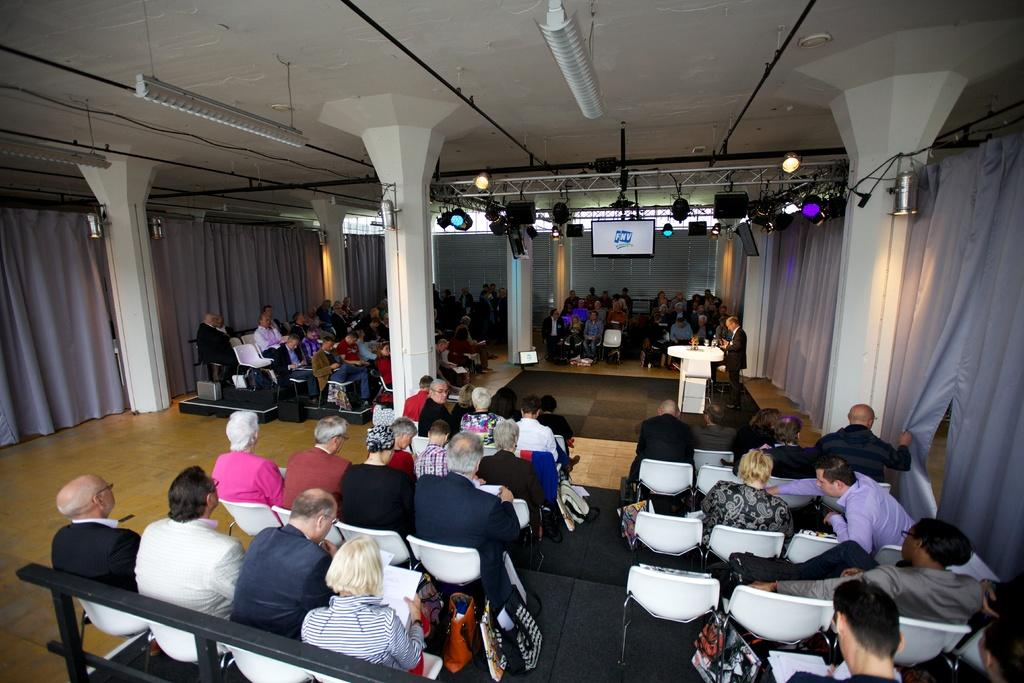What are the people in the image doing? There is a group of people sitting on chairs in the image. What can be seen near the group of people? There is a man standing near a podium in the image. What is visible at the top of the image? There are lights visible at the top of the image. What discovery was made by the group of people in the image? There is no indication of a discovery being made in the image; it simply shows a group of people sitting on chairs and a man standing near a podium. What is the man's level of anger in the image? There is no indication of the man's emotions, such as anger, in the image. 